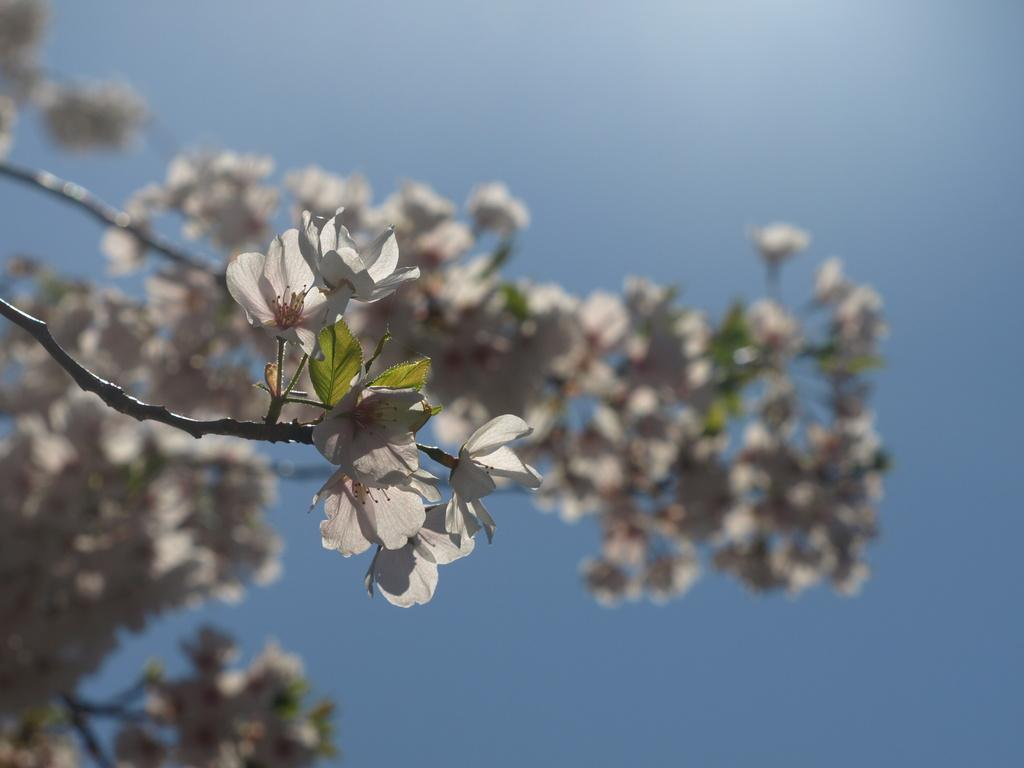What type of plant is visible in the image? There is a flower plant in the image. Can you describe the background of the image? The background of the image is blurred. How many leather sticks are visible in the image? There are no leather sticks present in the image. What type of geese can be seen in the image? There are no geese present in the image. 